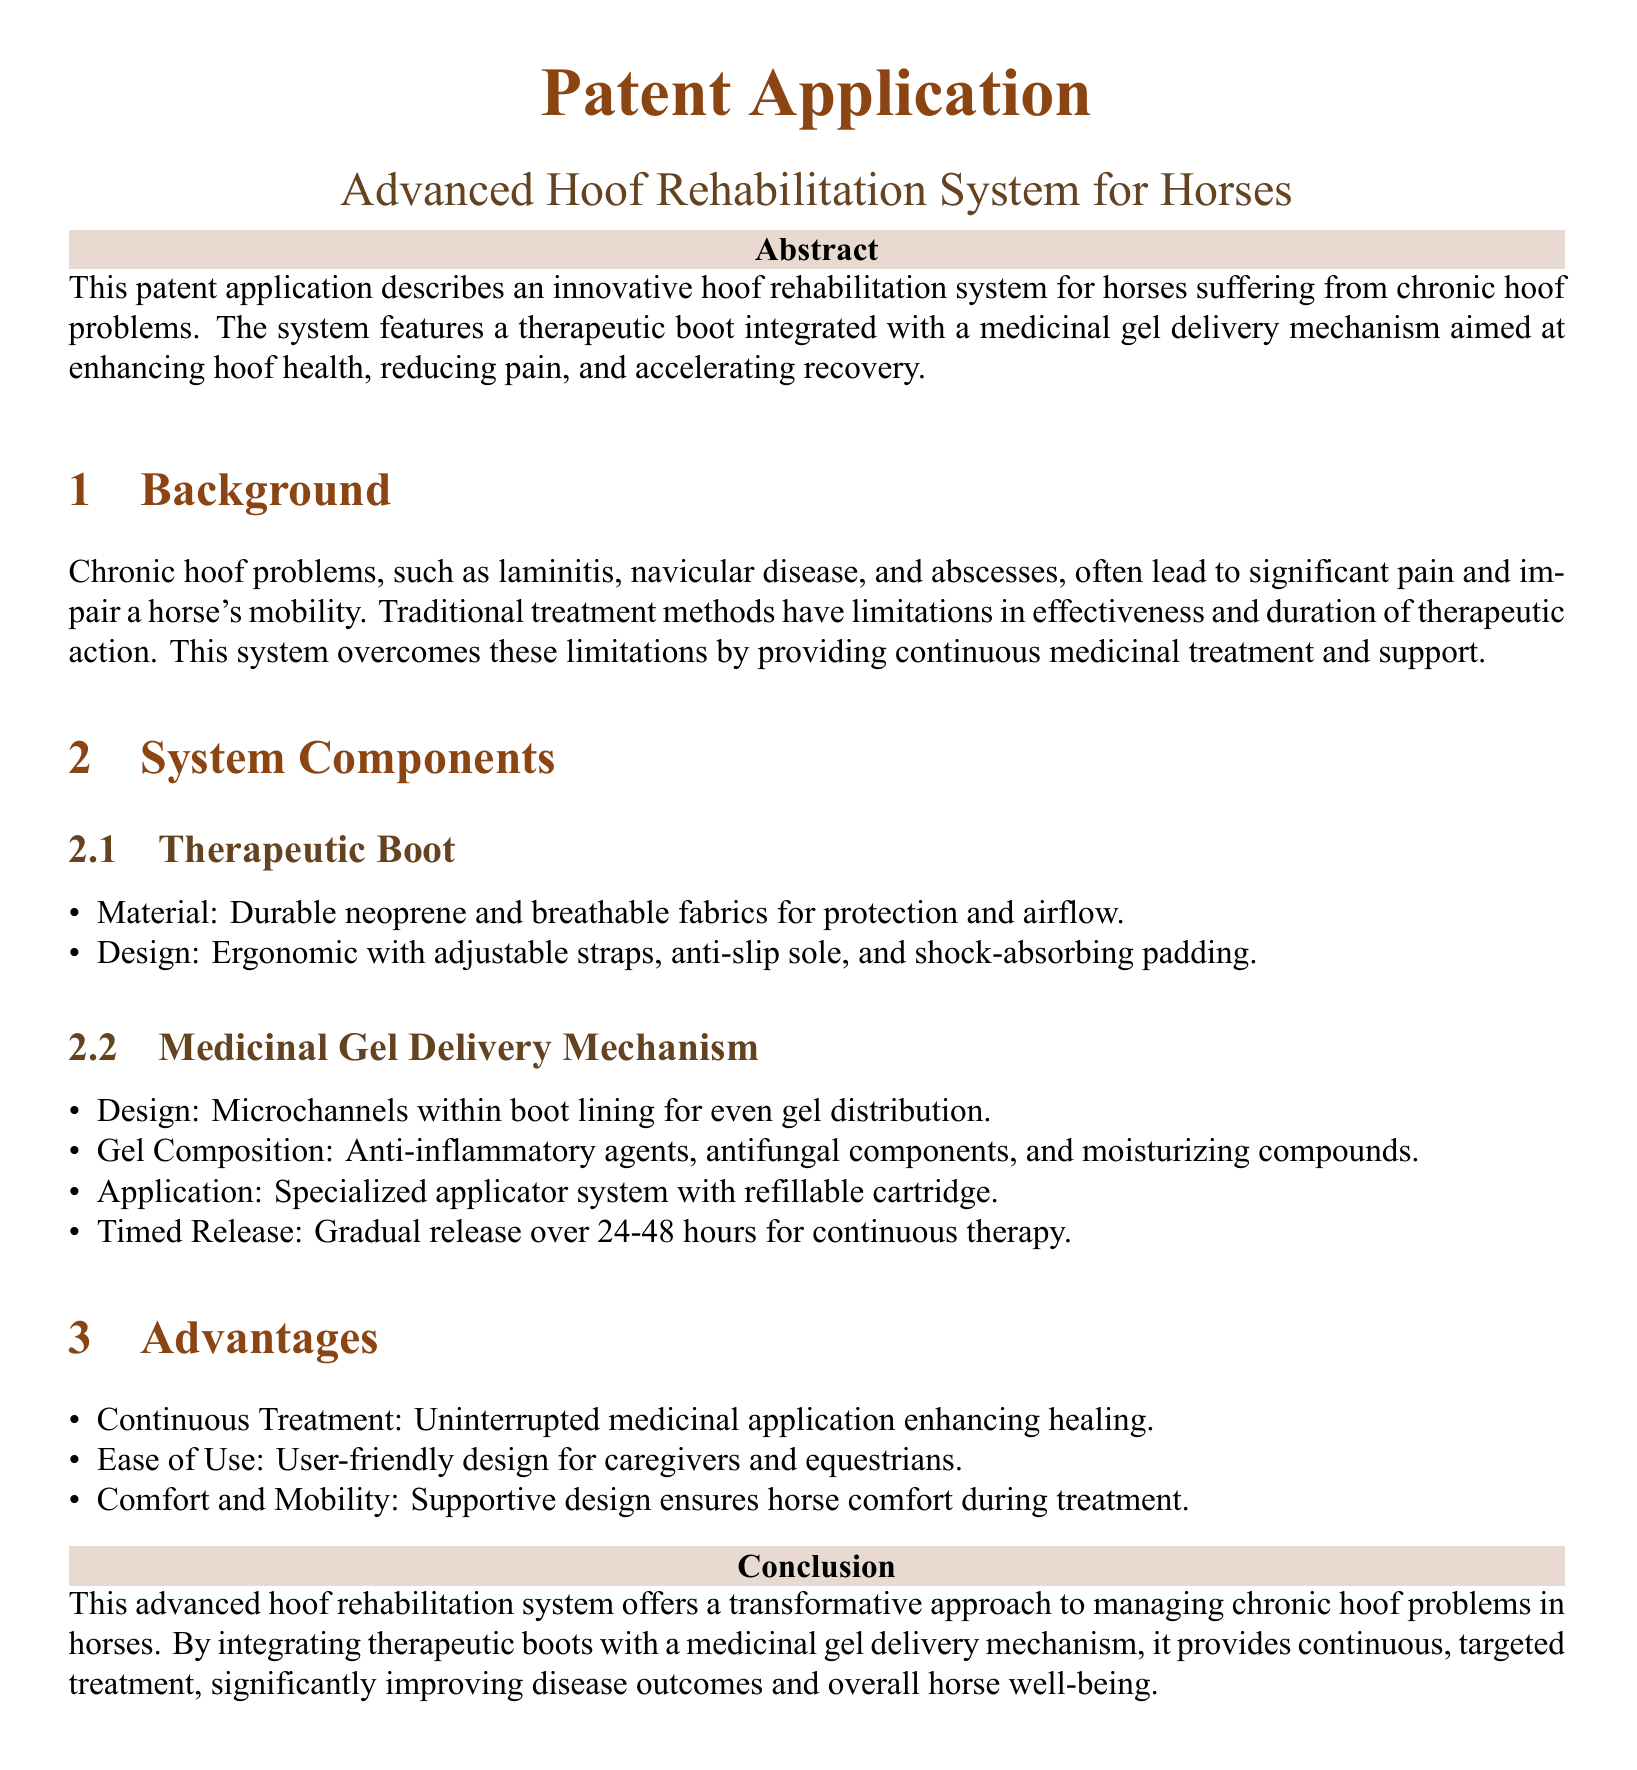What is the main focus of the patent application? The main focus of the application is an innovative hoof rehabilitation system for horses suffering from chronic hoof problems.
Answer: hoof rehabilitation system What materials are used for the therapeutic boot? The document specifies that the therapeutic boot is made from durable neoprene and breathable fabrics for protection and airflow.
Answer: neoprene and breathable fabrics What are the key benefits of the system? The advantages section lists benefits such as continuous treatment, ease of use, and comfort and mobility.
Answer: continuous treatment, ease of use, comfort and mobility How long does the medicinal gel release last? The document states that the gel provides a gradual release over 24-48 hours for continuous therapy.
Answer: 24-48 hours Which chronic hoof problems does the system address? The background section mentions chronic hoof problems including laminitis, navicular disease, and abscesses.
Answer: laminitis, navicular disease, abscesses What feature ensures even gel distribution? The system uses microchannels within the boot lining for even gel distribution.
Answer: microchannels What is the purpose of the specialized applicator system? The specialized applicator system allows for gel application with a refillable cartridge.
Answer: refillable cartridge What type of document is this? The document is a patent application describing a specific invention.
Answer: patent application 